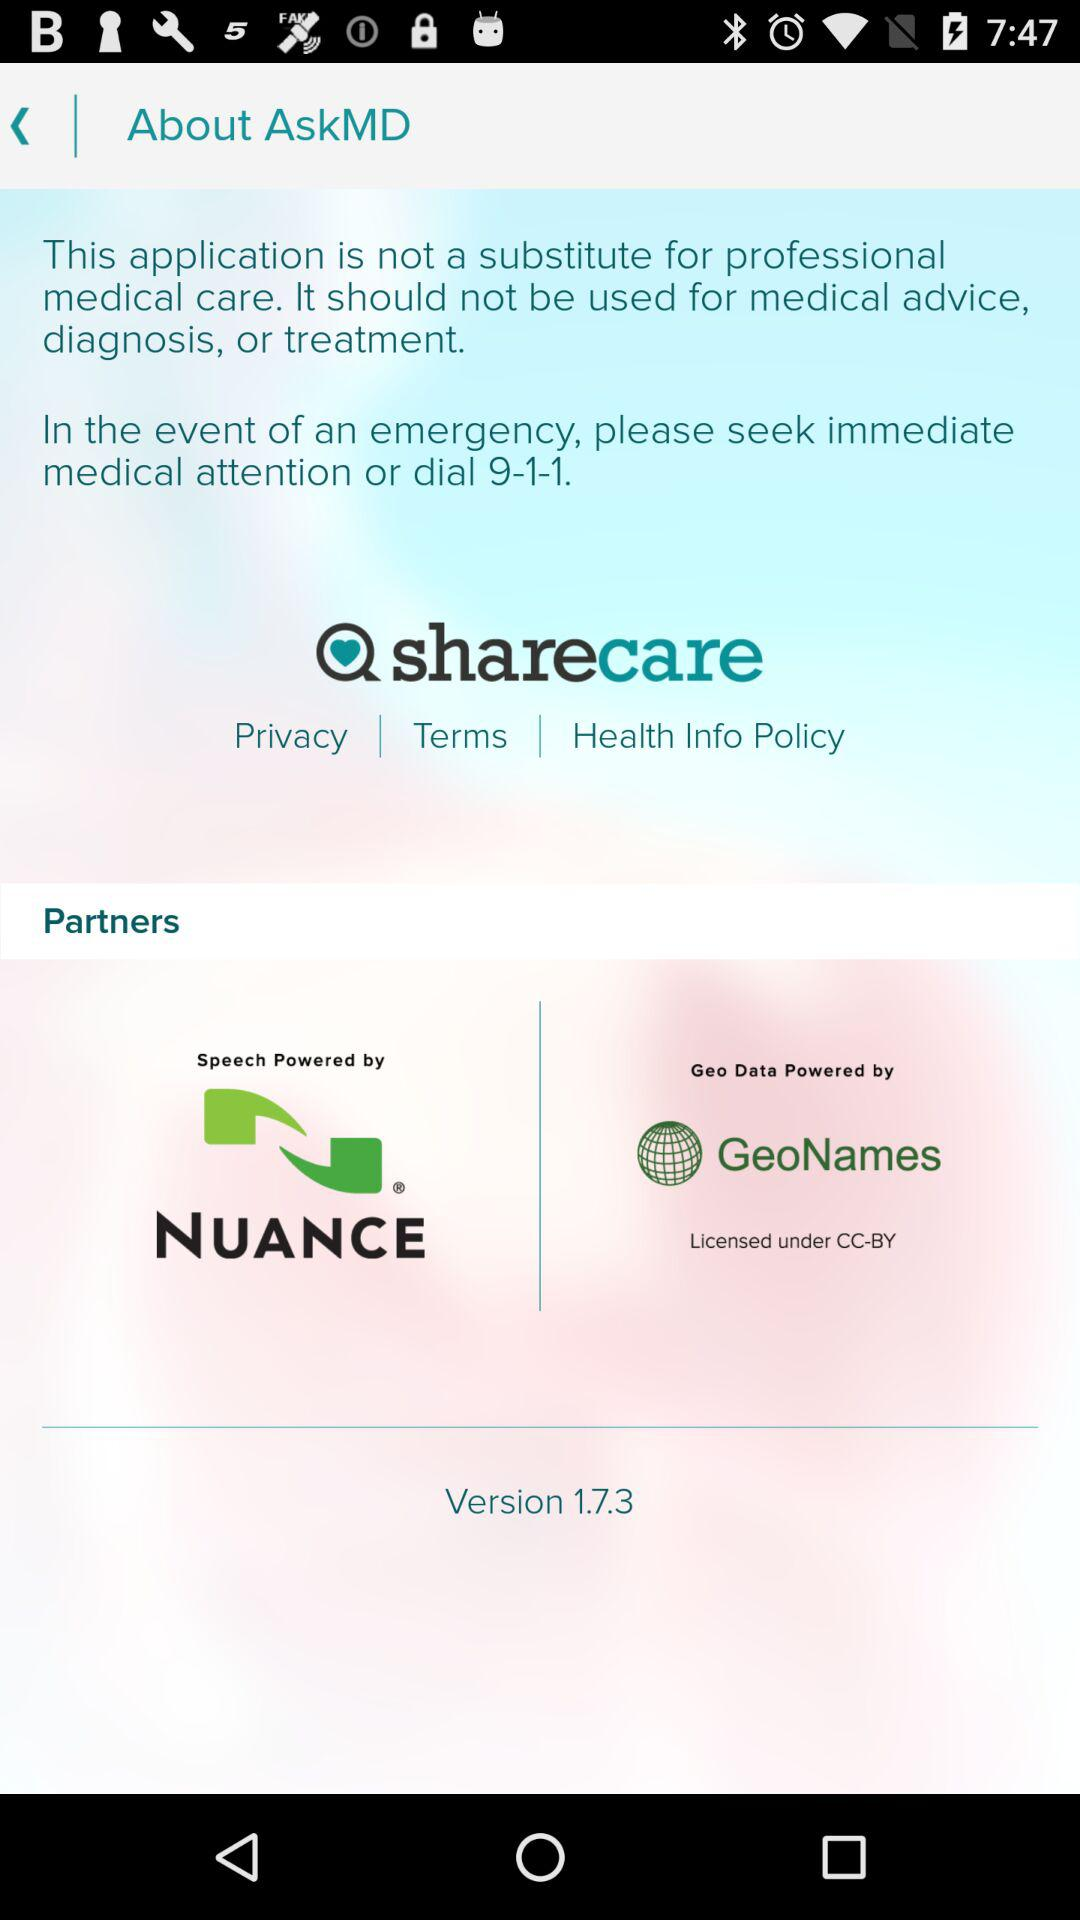What is the version of the application? The version of the application is 1.7.3. 